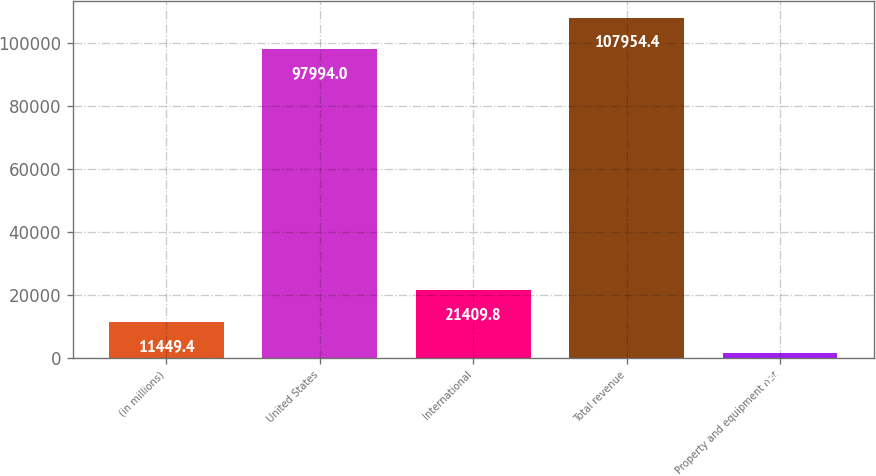Convert chart. <chart><loc_0><loc_0><loc_500><loc_500><bar_chart><fcel>(in millions)<fcel>United States<fcel>International<fcel>Total revenue<fcel>Property and equipment net<nl><fcel>11449.4<fcel>97994<fcel>21409.8<fcel>107954<fcel>1489<nl></chart> 